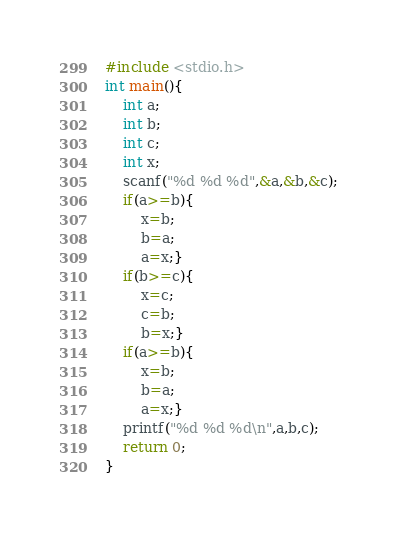<code> <loc_0><loc_0><loc_500><loc_500><_C_>#include <stdio.h>
int main(){
	int a;
	int b;
	int c;
	int x;
	scanf("%d %d %d",&a,&b,&c);
	if(a>=b){
		x=b;
		b=a;
		a=x;}
	if(b>=c){
		x=c;
		c=b;
		b=x;}
	if(a>=b){
		x=b;
		b=a;
		a=x;}
	printf("%d %d %d\n",a,b,c);
	return 0;
}</code> 